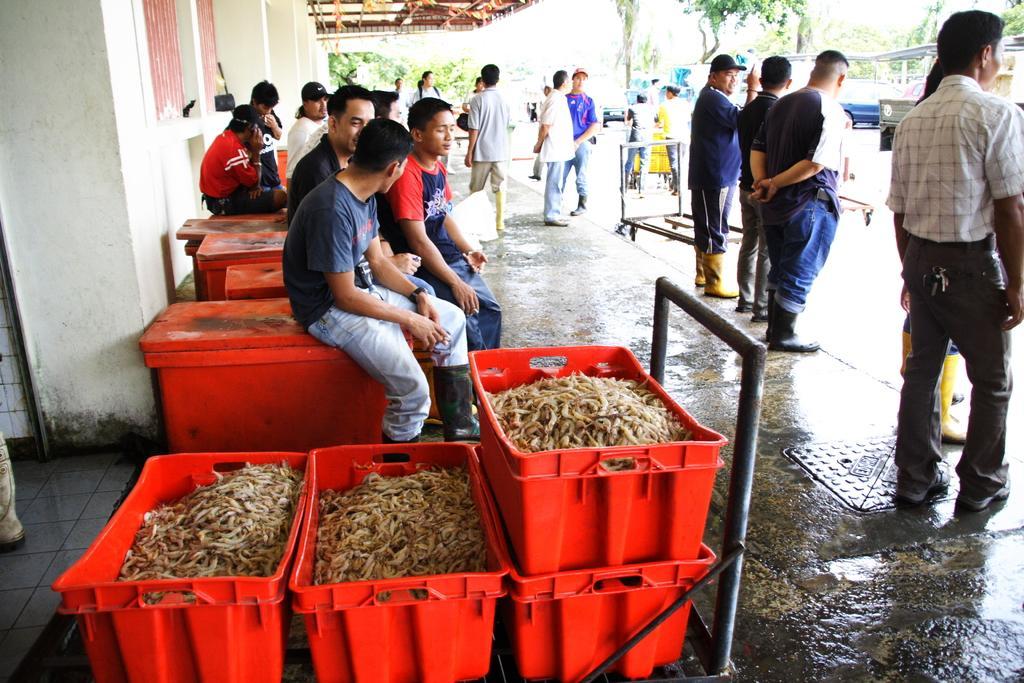In one or two sentences, can you explain what this image depicts? There are few people standing and few people sitting. I can see the prawns, which are in the red baskets. This looks like a building. In the background, I can see a tree. I think these are the vehicles. 